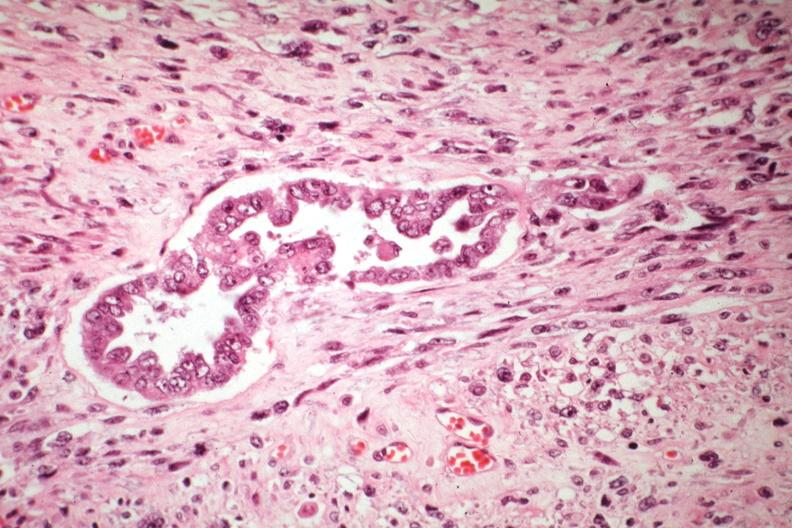where is this from?
Answer the question using a single word or phrase. Female reproductive system 